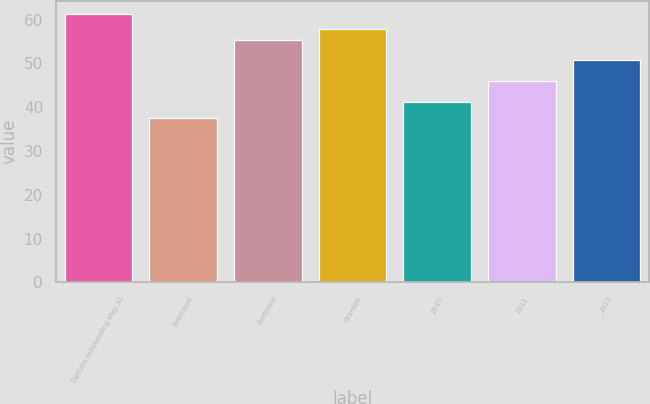<chart> <loc_0><loc_0><loc_500><loc_500><bar_chart><fcel>Options outstanding May 31<fcel>Exercised<fcel>Forfeited<fcel>Granted<fcel>2010<fcel>2011<fcel>2012<nl><fcel>61.18<fcel>37.64<fcel>55.44<fcel>57.79<fcel>41.16<fcel>46.04<fcel>50.74<nl></chart> 